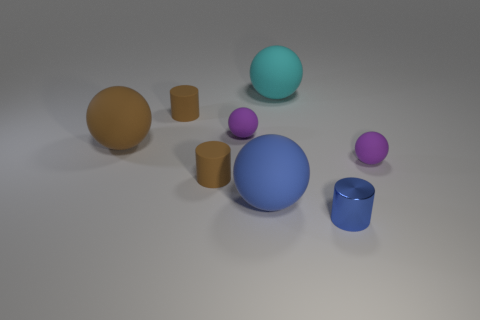What number of things are tiny objects behind the small blue cylinder or small cylinders that are right of the large blue rubber object?
Offer a terse response. 5. Are there the same number of small shiny cylinders that are in front of the small blue cylinder and big blue matte things that are in front of the blue rubber thing?
Keep it short and to the point. Yes. What shape is the brown rubber object that is in front of the tiny purple matte ball to the right of the small metallic object?
Offer a very short reply. Cylinder. Is there another matte object of the same shape as the big brown matte object?
Provide a succinct answer. Yes. How many small rubber cylinders are there?
Ensure brevity in your answer.  2. Do the purple ball on the right side of the tiny blue metal cylinder and the cyan object have the same material?
Offer a terse response. Yes. Is there a cyan object of the same size as the brown ball?
Your answer should be very brief. Yes. There is a small blue thing; is its shape the same as the purple rubber thing right of the cyan matte ball?
Keep it short and to the point. No. There is a purple matte sphere that is right of the cylinder right of the large cyan matte ball; is there a small rubber thing behind it?
Offer a terse response. Yes. The brown rubber ball is what size?
Provide a short and direct response. Large. 